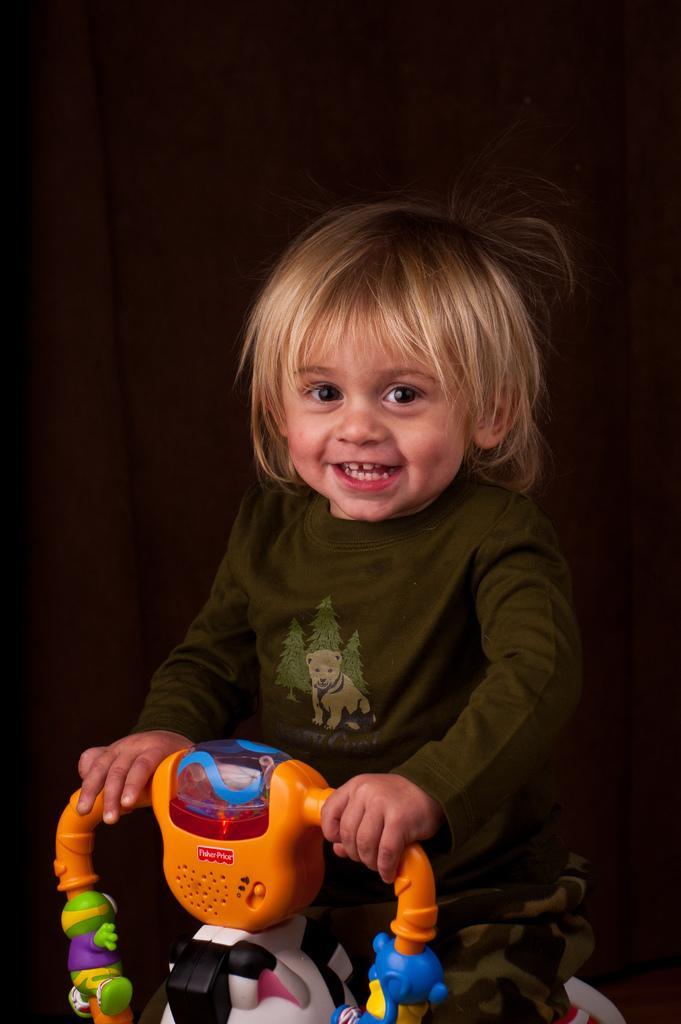Can you describe this image briefly? In the center of the image, we can see a kid smiling and sitting on the grow ride. In the background, there is a wall. 